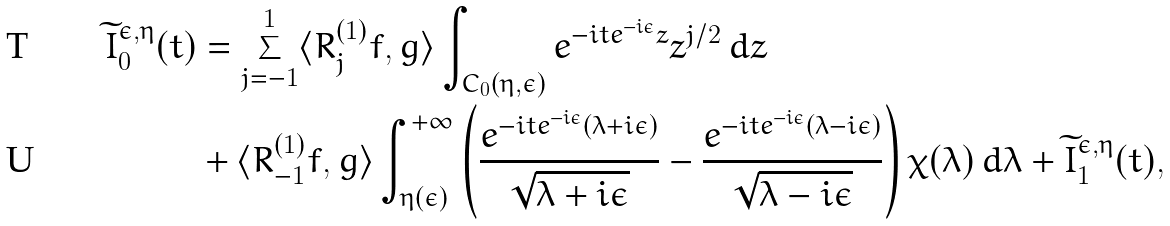<formula> <loc_0><loc_0><loc_500><loc_500>\widetilde { I } _ { 0 } ^ { \epsilon , \eta } ( t ) & = \sum _ { j = - 1 } ^ { 1 } \langle R _ { j } ^ { ( 1 ) } f , g \rangle \int _ { C _ { 0 } ( \eta , \epsilon ) } e ^ { - i t e ^ { - i \epsilon } z } z ^ { j / 2 } \, d z \\ & + \langle R _ { - 1 } ^ { ( 1 ) } f , g \rangle \int _ { \eta ( \epsilon ) } ^ { + \infty } \left ( \frac { e ^ { - i t e ^ { - i \epsilon } ( \lambda + i \epsilon ) } } { \sqrt { \lambda + i \epsilon } } - \frac { e ^ { - i t e ^ { - i \epsilon } ( \lambda - i \epsilon ) } } { \sqrt { \lambda - i \epsilon } } \right ) \chi ( \lambda ) \, d \lambda + \widetilde { I } _ { 1 } ^ { \epsilon , \eta } ( t ) ,</formula> 